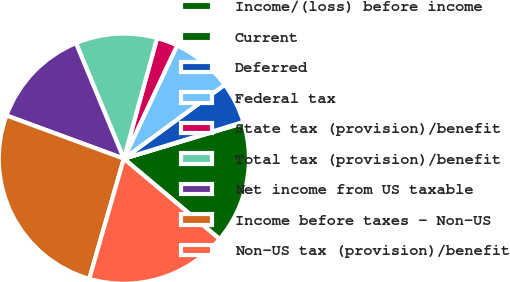<chart> <loc_0><loc_0><loc_500><loc_500><pie_chart><fcel>Income/(loss) before income<fcel>Current<fcel>Deferred<fcel>Federal tax<fcel>State tax (provision)/benefit<fcel>Total tax (provision)/benefit<fcel>Net income from US taxable<fcel>Income before taxes - Non-US<fcel>Non-US tax (provision)/benefit<nl><fcel>15.74%<fcel>0.12%<fcel>5.33%<fcel>7.93%<fcel>2.72%<fcel>10.53%<fcel>13.14%<fcel>26.15%<fcel>18.34%<nl></chart> 